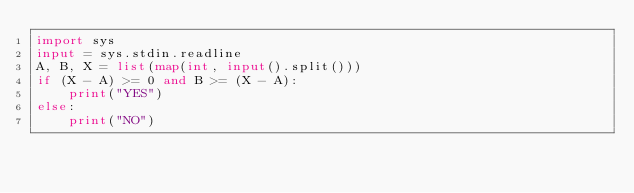Convert code to text. <code><loc_0><loc_0><loc_500><loc_500><_Python_>import sys
input = sys.stdin.readline
A, B, X = list(map(int, input().split()))
if (X - A) >= 0 and B >= (X - A):
    print("YES")
else:
    print("NO")</code> 